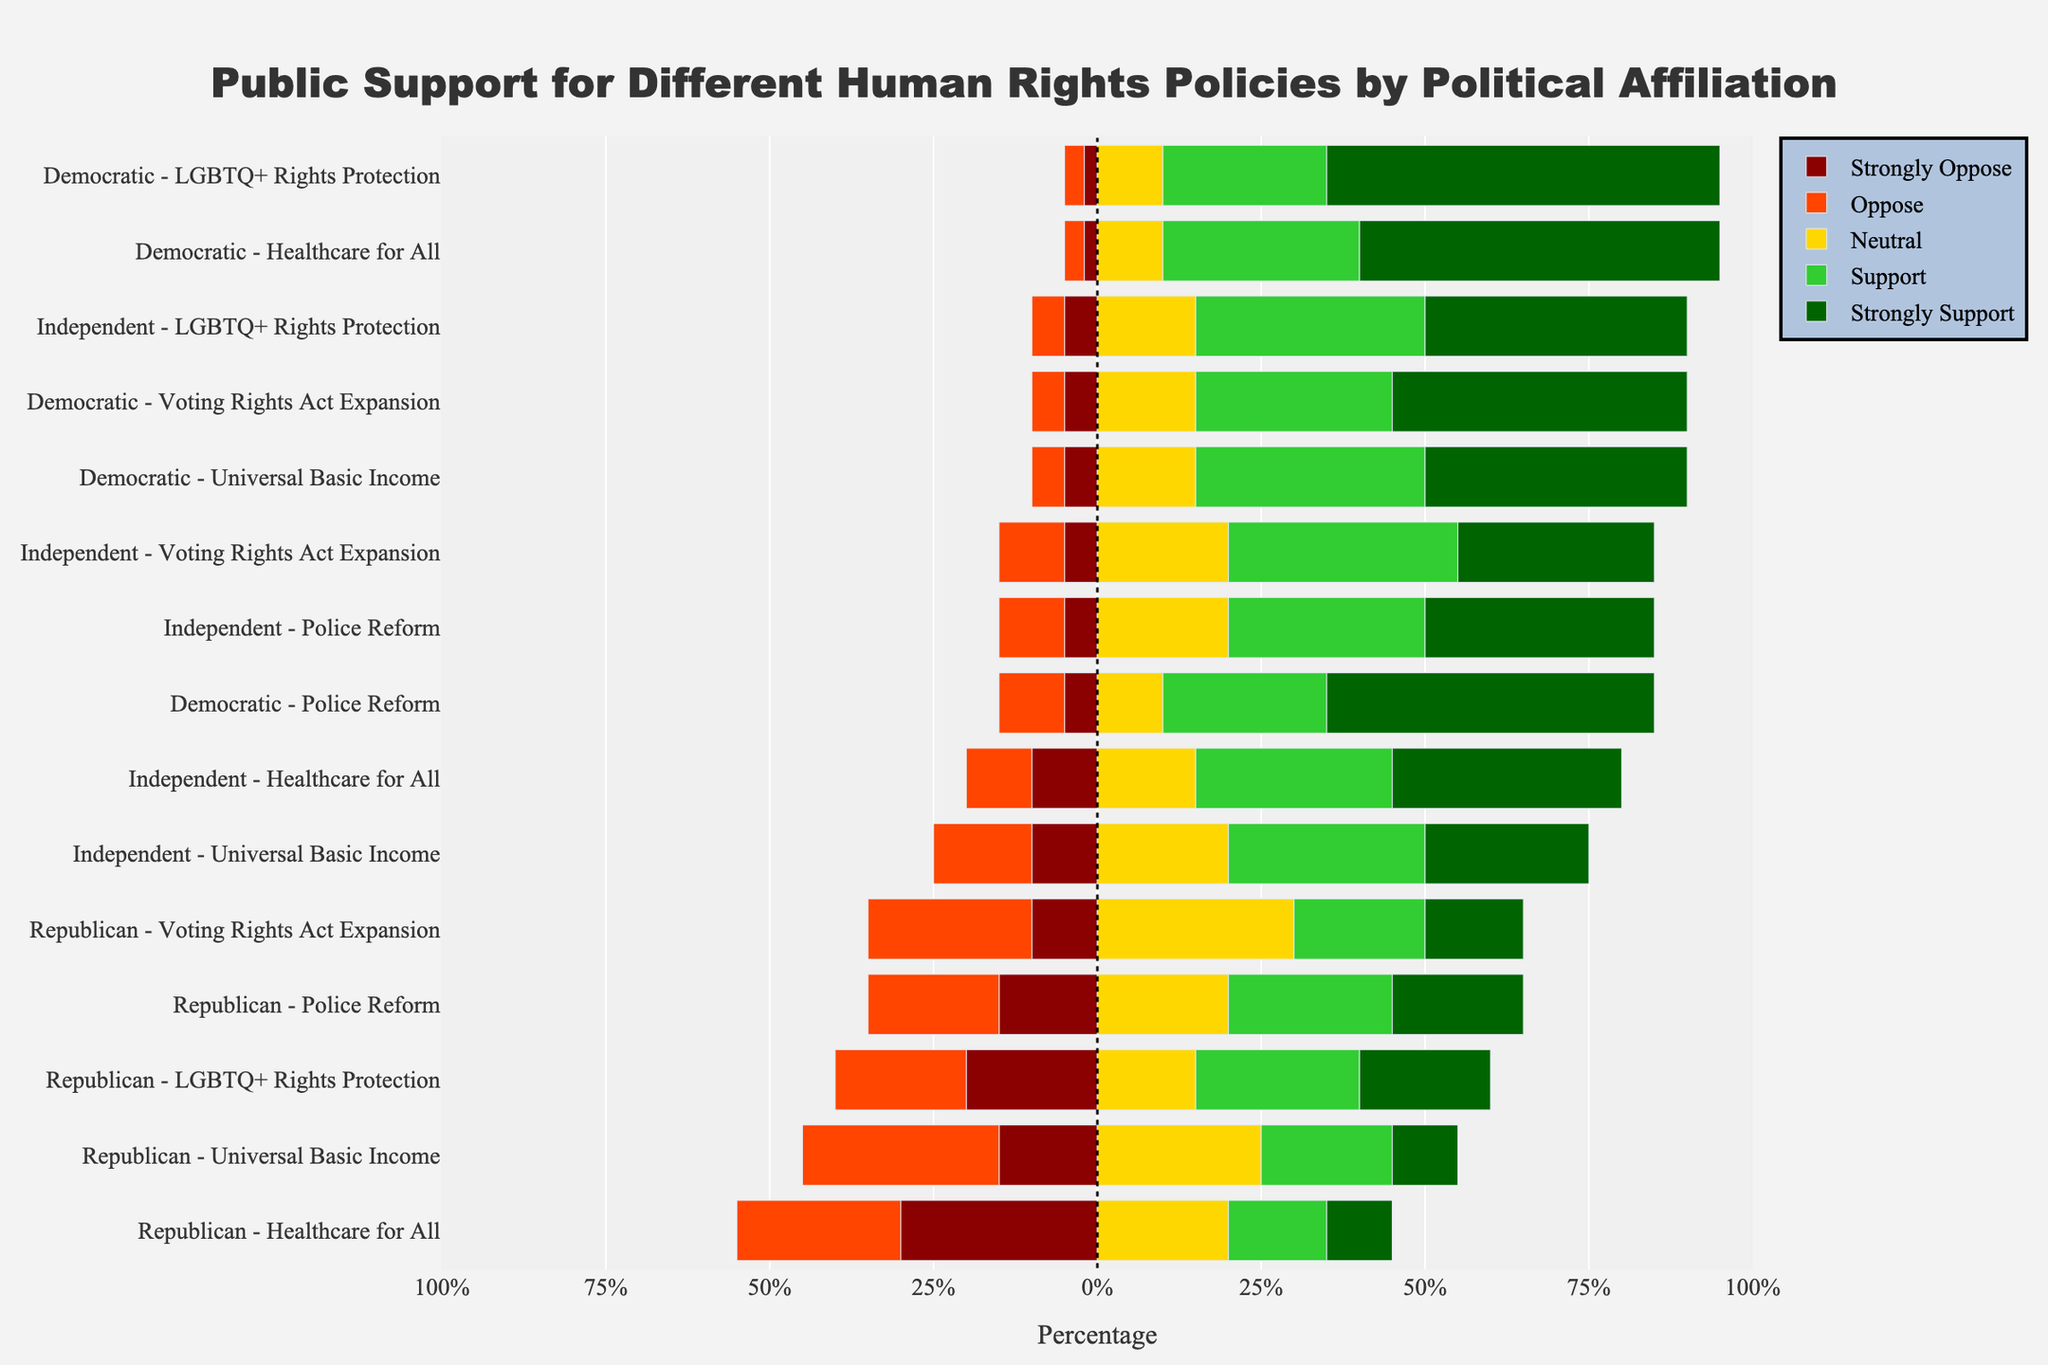Which political affiliation has the highest percentage of strongly supporting the Voting Rights Act Expansion? To find the political affiliation with the highest percentage of strongly supporting the Voting Rights Act Expansion, look at the length of the green bar (Strongly Support) for each political affiliation in the Voting Rights Act Expansion category. The Democratic affiliation has the longest green bar, indicating 45%.
Answer: Democratic How does the percentage of those who oppose Universal Basic Income differ between Republicans and Independents? Find the length of the red bar (Oppose) for each affiliation in the Universal Basic Income category. For Republicans, the red bar is 30%, and for Independents, it's 15%. The difference is 30% - 15% = 15%.
Answer: 15% What is the sum of the percentages of Democrats who support and strongly support Healthcare for All? For Democrats supporting Healthcare for All, add the length of the yellow and green bars. Support is 30%, and Strongly Support is 55%. The sum is 30% + 55% = 85%.
Answer: 85% Which policy has the least support (Support + Strongly Support) among Republicans? Sum the lengths of the yellow and green bars for each policy in the Republican category. The Healthcare for All policy has the smallest combined yellow and green bars, with Support at 15% and Strongly Support at 10%, totaling 25%.
Answer: Healthcare for All How does the percentage of Independents who strongly oppose Police Reform compare to that of Democrats? Look at the length of the dark red bar (Strongly Oppose) for Independents and Democrats in the Police Reform category. Independents have 5% and Democrats have 5%; thus, the percentages are equal.
Answer: Equal What is the total percentage of Republicans who have a neutral or positive (Support + Strongly Support) stance on LGBTQ+ Rights Protection? Sum the lengths of the grey, yellow, and green bars for Republicans in the LGBTQ+ Rights Protection category. Neutral is 15%, Support is 25%, and Strongly Support is 20%. The total is 15% + 25% + 20% = 60%.
Answer: 60% How does the percentage of Democrats who oppose the Voting Rights Act Expansion compare to the percentage of Republicans who oppose the same policy? Add the lengths of the red and dark red bars (Oppose and Strongly Oppose) for both affiliations. For Democrats: 5% (Oppose) + 5% (Strongly Oppose) = 10%. For Republicans: 25% (Oppose) + 10% (Strongly Oppose) = 35%. The difference is 35% - 10% = 25%.
Answer: Republicans by 25% Which policy has the highest percentage of strong opposition among Independents? Observe the length of the dark red bar (Strongly Oppose) for each policy under the Independent affiliation. The Universal Basic Income policy has 10%, which is the highest.
Answer: Universal Basic Income What is the average percentage of Democrats who oppose Universal Basic Income and Healthcare for All? First, find the sum of percentages of Democrats opposing each policy. For Universal Basic Income, Oppose is 5% and Strongly Oppose is 5%, totaling 10%. For Healthcare for All, Oppose is 3% and Strongly Oppose is 2%, totaling 5%. The sum is 10% + 5% = 15%. Divide by the number of policies (2). The average is 15% / 2 = 7.5%.
Answer: 7.5% How does the neutral stance on Police Reform differ between political affiliations? Look at the grey bar (Neutral) in the Police Reform category for each affiliation. Democrats have 10%, Republicans have 20%, and Independents have 20%. The differences are: Democrat vs Republican: 20% - 10% = 10%; Democrat vs Independent: 20% - 10% = 10%; Republican vs Independent: 20% - 20% = 0%.
Answer: 10%, 10%, 0% 